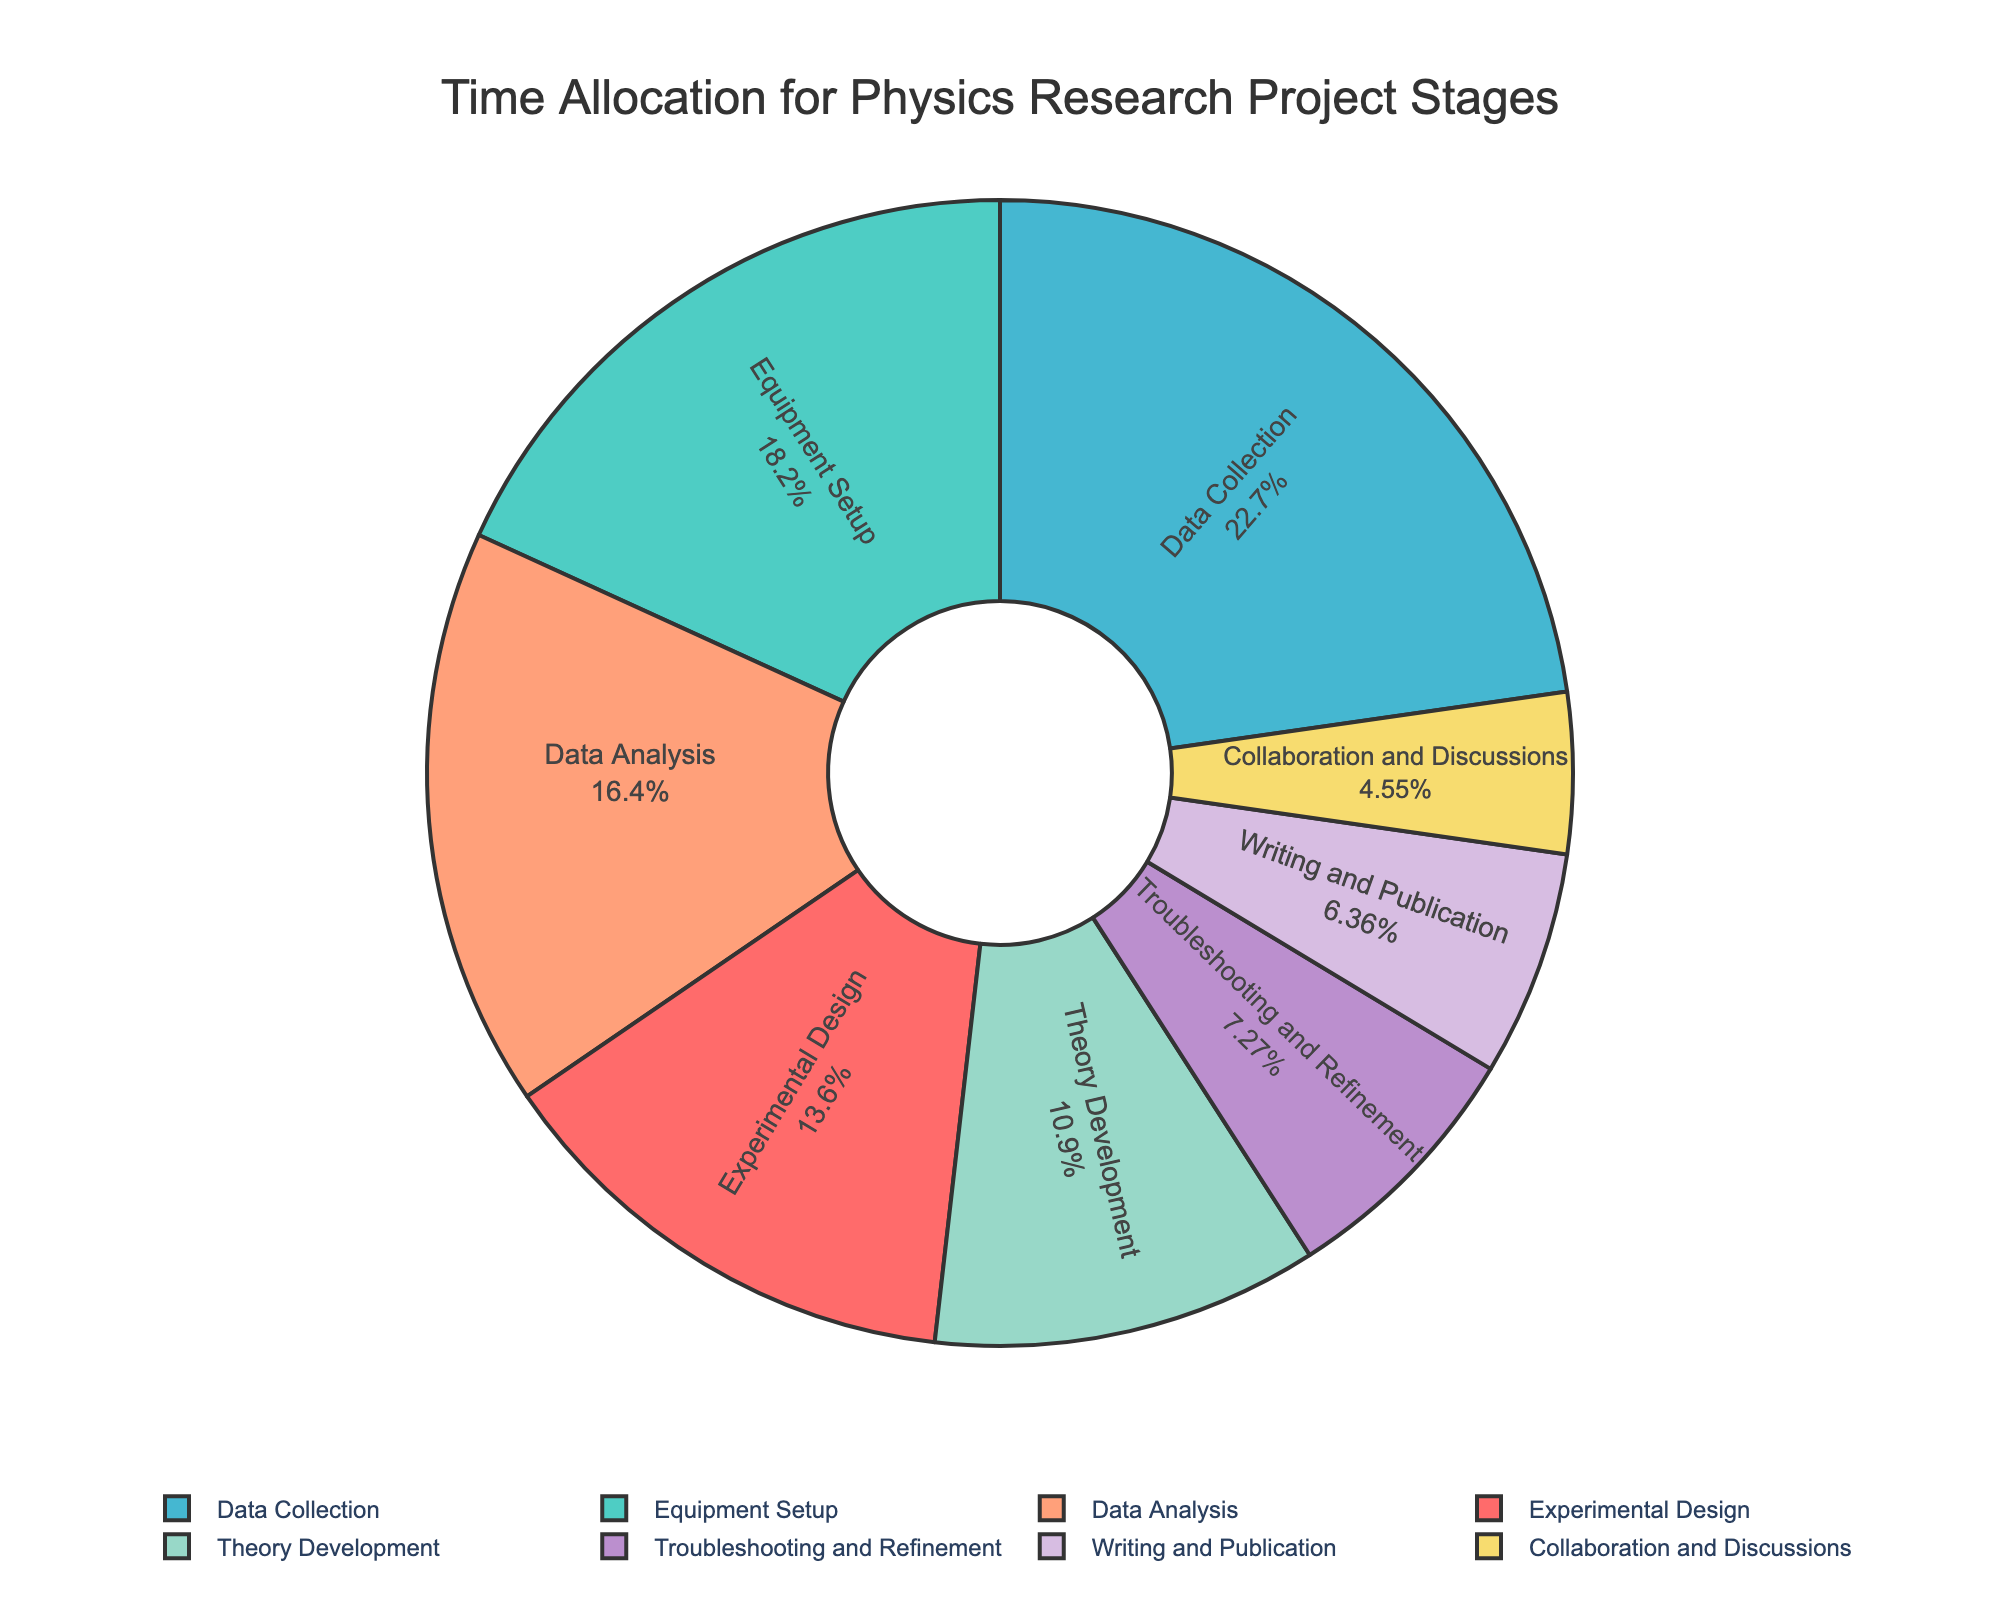What percentage is allocated to Equipment Setup? Locate the segment for Equipment Setup in the pie chart and read off its percentage.
Answer: 20% Which stages combined take up more time: Data Collection and Experimental Design, or Data Analysis and Theory Development? Sum the percentages for Data Collection (25%) and Experimental Design (15%), which is 40%. Then sum the percentages for Data Analysis (18%) and Theory Development (12%), which is 30%. 40% is greater than 30%.
Answer: Data Collection and Experimental Design What's the smallest time allocation stage shown in the chart? Identify the stage with the smallest percentage, which is Collaboration and Discussions at 5%.
Answer: Collaboration and Discussions How much more time is allocated to Troubleshooting and Refinement compared to Writing and Publication? The percentage for Troubleshooting and Refinement is 8%, and for Writing and Publication is 7%. The difference is 8% - 7%.
Answer: 1% Which two stages together almost account for an equal amount of time spent as Data Collection alone? Data Collection is 25%. Find two stages with a combined total close to 25%. Experimental Design (15%) and Writing and Publication (7%) sum to 22%, which is close.
Answer: Experimental Design and Writing and Publication What proportion of time is spent on Equipment Setup relative to Theory Development? Equipment Setup is 20%, and Theory Development is 12%. The proportion is calculated as 20% / 12%.
Answer: 5:3 or 1.67 times Among the data-driven stages (Data Collection and Data Analysis), which one has a larger time allocation and by how much? Data Collection is 25%, and Data Analysis is 18%. The difference is 25% - 18%.
Answer: Data Collection by 7% From the visual representation, which stage is depicted with a yellow segment? Identify the stage colored in yellow, which is Collaboration and Discussions.
Answer: Collaboration and Discussions What is the combined time allocation for the stages excluding Data Collection? Sum all the stage percentages except Data Collection (25%): 15% + 20% + 18% + 12% + 5% + 8% + 7% = 85%.
Answer: 85% How much more time is spent on Equipment Setup compared to Collaboration and Discussions and Writing and Publication combined? Collaboration and Discussions (5%) and Writing and Publication (7%) sum to 12%. Equipment Setup is 20%. The difference is 20% - 12%.
Answer: 8% 